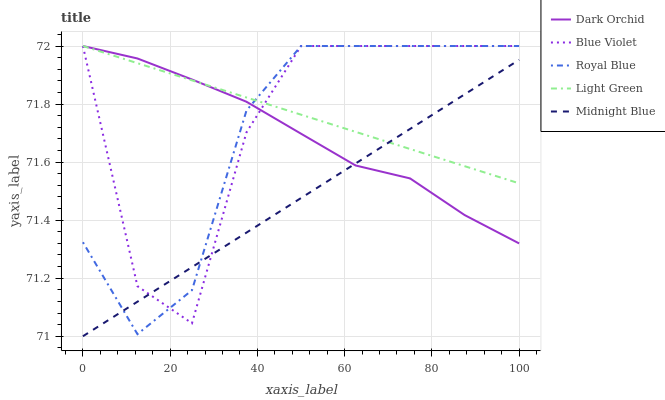Does Midnight Blue have the minimum area under the curve?
Answer yes or no. Yes. Does Light Green have the maximum area under the curve?
Answer yes or no. Yes. Does Blue Violet have the minimum area under the curve?
Answer yes or no. No. Does Blue Violet have the maximum area under the curve?
Answer yes or no. No. Is Light Green the smoothest?
Answer yes or no. Yes. Is Blue Violet the roughest?
Answer yes or no. Yes. Is Blue Violet the smoothest?
Answer yes or no. No. Is Light Green the roughest?
Answer yes or no. No. Does Midnight Blue have the lowest value?
Answer yes or no. Yes. Does Blue Violet have the lowest value?
Answer yes or no. No. Does Dark Orchid have the highest value?
Answer yes or no. Yes. Does Midnight Blue have the highest value?
Answer yes or no. No. Does Midnight Blue intersect Dark Orchid?
Answer yes or no. Yes. Is Midnight Blue less than Dark Orchid?
Answer yes or no. No. Is Midnight Blue greater than Dark Orchid?
Answer yes or no. No. 